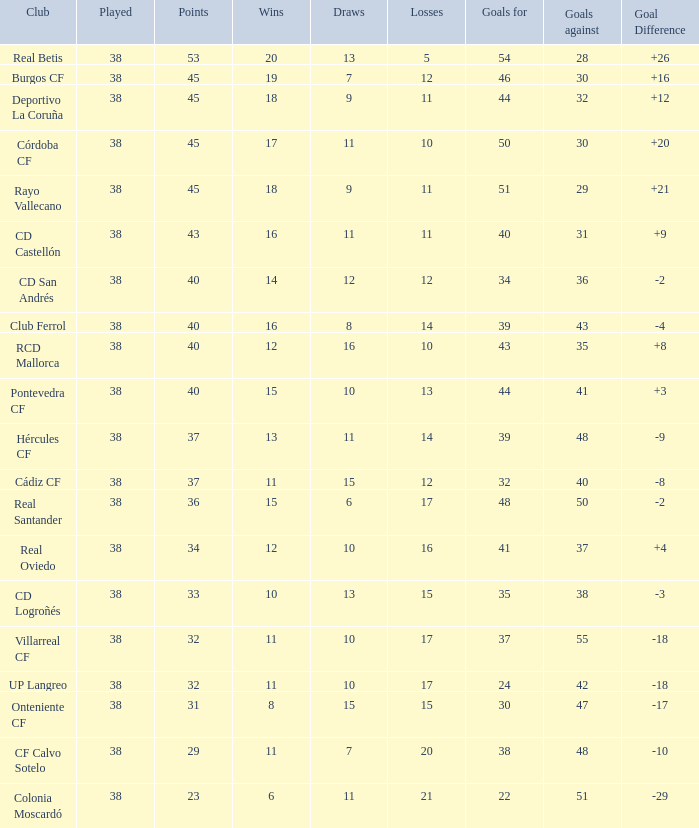What is the mean draws, when goal difference exceeds -3, when goals against equals 30, and when points surpass 45? None. 